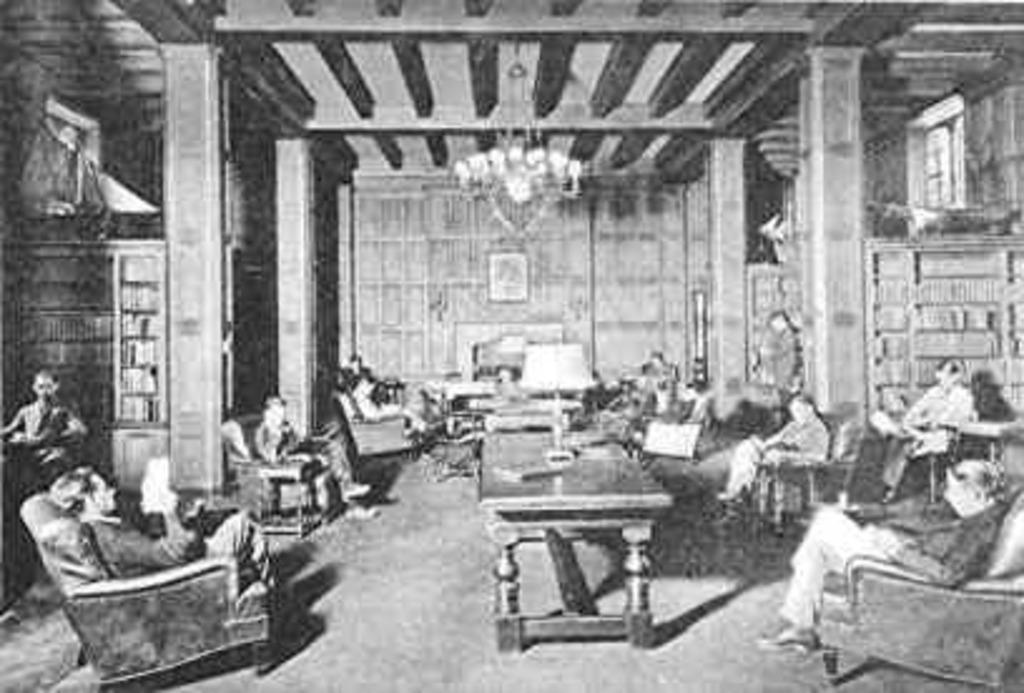Can you describe this image briefly? In a picture it is an old photograph in which people are sitting on a chair and doing some work there there is a table in front of them on the table there is a lamp above the table on the roof there is also a lamp there are some shelf in the shelf there are some books there are four pillars. 